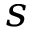<formula> <loc_0><loc_0><loc_500><loc_500>s</formula> 